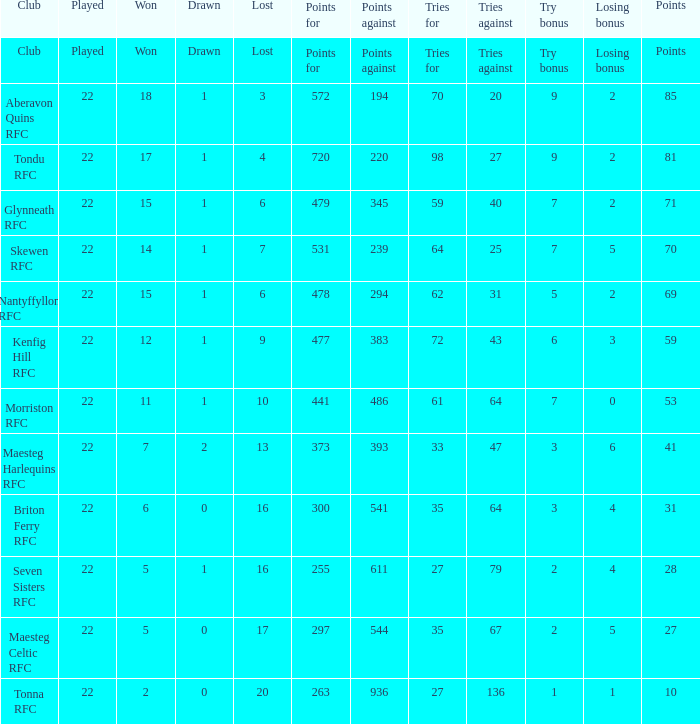What club got 239 points against? Skewen RFC. 